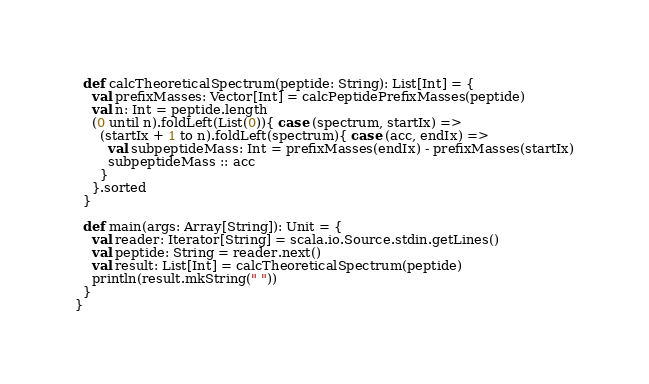<code> <loc_0><loc_0><loc_500><loc_500><_Scala_>  def calcTheoreticalSpectrum(peptide: String): List[Int] = {
    val prefixMasses: Vector[Int] = calcPeptidePrefixMasses(peptide)
    val n: Int = peptide.length
    (0 until n).foldLeft(List(0)){ case (spectrum, startIx) =>
      (startIx + 1 to n).foldLeft(spectrum){ case (acc, endIx) =>
        val subpeptideMass: Int = prefixMasses(endIx) - prefixMasses(startIx)
        subpeptideMass :: acc
      }
    }.sorted
  }

  def main(args: Array[String]): Unit = {
    val reader: Iterator[String] = scala.io.Source.stdin.getLines()
    val peptide: String = reader.next()
    val result: List[Int] = calcTheoreticalSpectrum(peptide)
    println(result.mkString(" "))
  }
}
</code> 